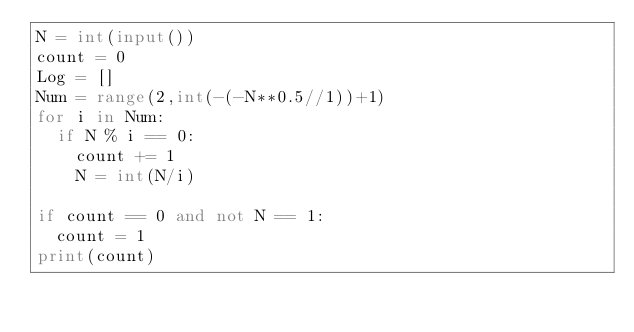<code> <loc_0><loc_0><loc_500><loc_500><_Python_>N = int(input())
count = 0
Log = []
Num = range(2,int(-(-N**0.5//1))+1)
for i in Num:
  if N % i == 0:
    count += 1
    N = int(N/i)
      
if count == 0 and not N == 1:
  count = 1
print(count)</code> 